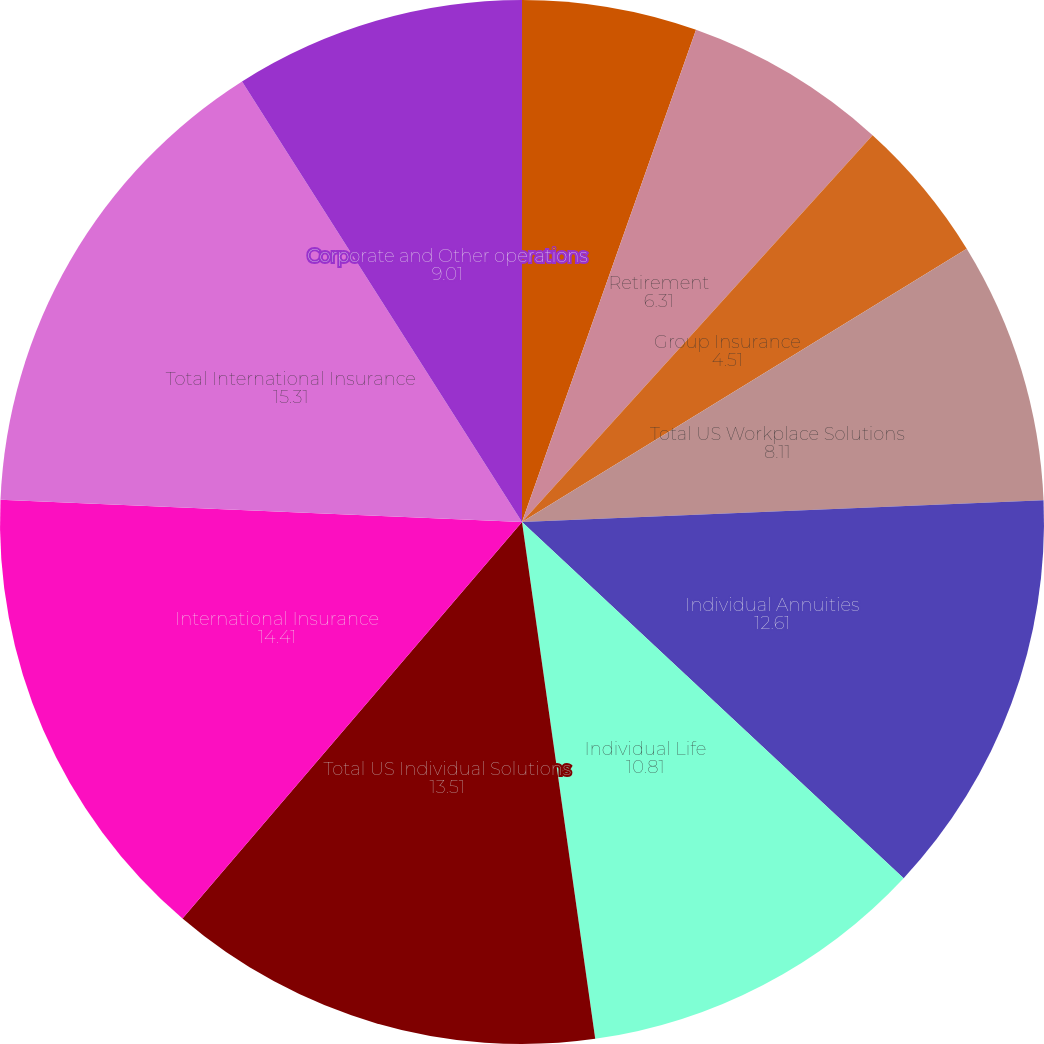<chart> <loc_0><loc_0><loc_500><loc_500><pie_chart><fcel>Total PGIM division(1)<fcel>Retirement<fcel>Group Insurance<fcel>Total US Workplace Solutions<fcel>Individual Annuities<fcel>Individual Life<fcel>Total US Individual Solutions<fcel>International Insurance<fcel>Total International Insurance<fcel>Corporate and Other operations<nl><fcel>5.41%<fcel>6.31%<fcel>4.51%<fcel>8.11%<fcel>12.61%<fcel>10.81%<fcel>13.51%<fcel>14.41%<fcel>15.31%<fcel>9.01%<nl></chart> 